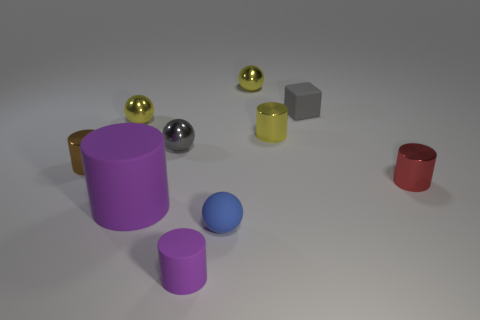Subtract all brown cylinders. How many cylinders are left? 4 Subtract all brown cylinders. How many cylinders are left? 4 Subtract all brown spheres. Subtract all cyan cylinders. How many spheres are left? 4 Subtract all balls. How many objects are left? 6 Subtract all small purple rubber objects. Subtract all tiny yellow balls. How many objects are left? 7 Add 9 tiny red metal things. How many tiny red metal things are left? 10 Add 9 tiny blue spheres. How many tiny blue spheres exist? 10 Subtract 1 red cylinders. How many objects are left? 9 